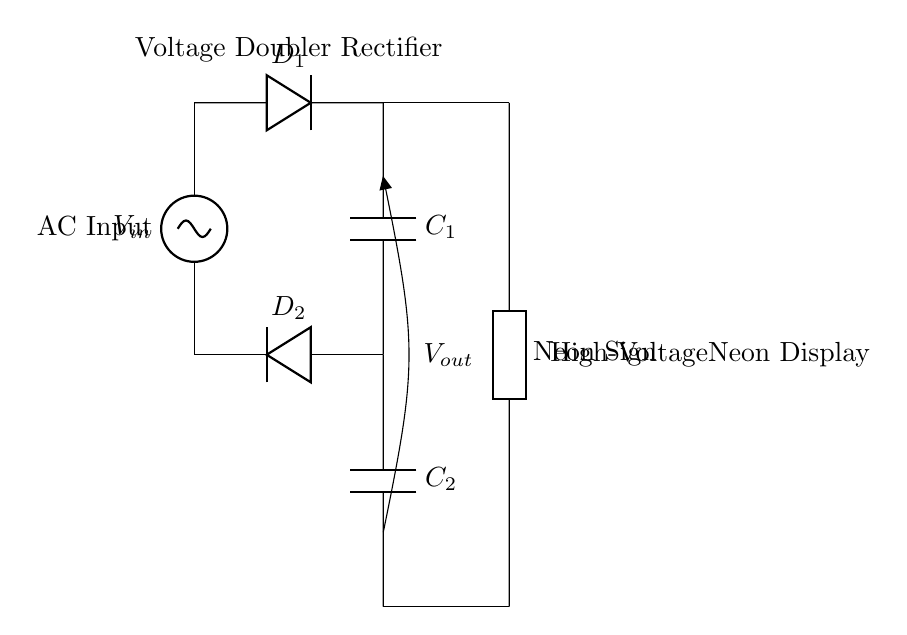What is the input voltage labeled in the circuit? The input voltage is labeled as V in. This is the voltage source that provides AC power to the circuit.
Answer: V in What components are used for the rectifying process? The components used for rectification are labeled as D1 and D2. These are diodes, which convert AC voltage to DC voltage by allowing current to flow in only one direction.
Answer: D1, D2 What is the purpose of capacitors C1 and C2? Capacitors C1 and C2 store electrical charge and smooth out the voltage output. They help in filtering and stabilizing the voltage for the neon sign load connected at the output.
Answer: Charge storage, voltage smoothing How many diodes are present in this circuit? The circuit has two diodes, D1 and D2, which are essential for the voltage doubling rectification process.
Answer: 2 What type of load is indicated at the output? The load at the output is labeled as a Neon Sign, which shows that the circuit is designed to operate neon sign displays requiring high voltage.
Answer: Neon Sign What is the function of the voltage doubler configuration? The voltage doubler configuration allows the circuit to effectively increase the voltage output, supplying higher voltage needed for the neon sign by using both diodes and capacitors in a specific arrangement.
Answer: Increase output voltage What is the output voltage at the end of this rectifier setup? The output voltage is labeled as V out, which represents the rectified and doubled voltage supplied to the neon sign load according to the configurations of the diodes and capacitors.
Answer: V out 